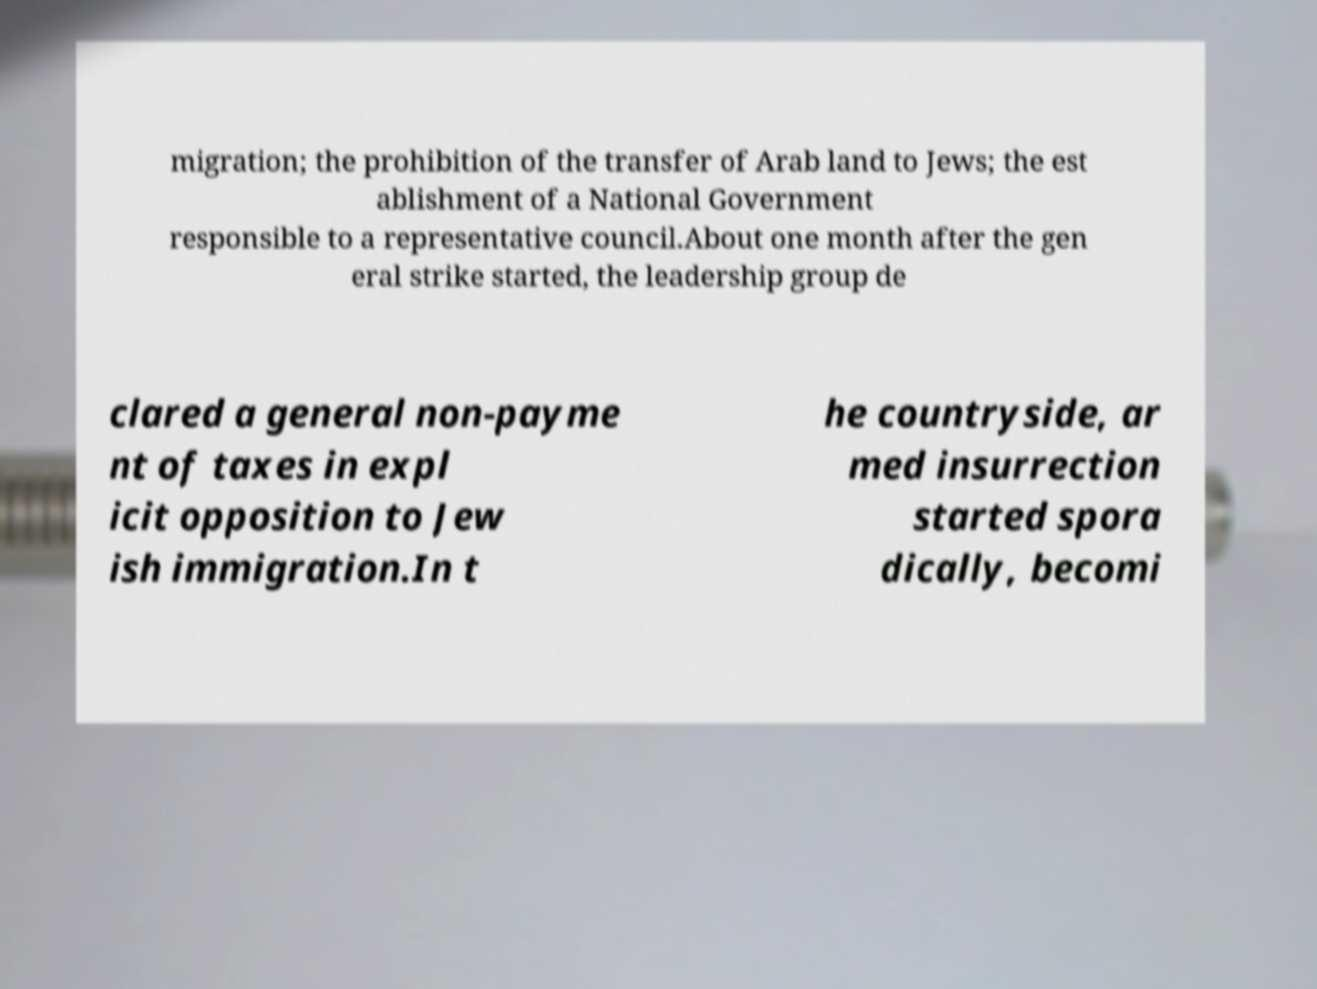Please identify and transcribe the text found in this image. migration; the prohibition of the transfer of Arab land to Jews; the est ablishment of a National Government responsible to a representative council.About one month after the gen eral strike started, the leadership group de clared a general non-payme nt of taxes in expl icit opposition to Jew ish immigration.In t he countryside, ar med insurrection started spora dically, becomi 